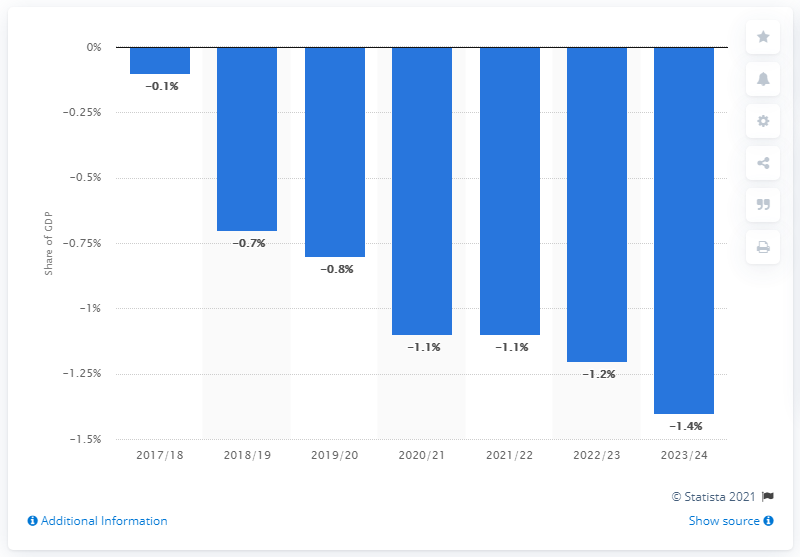How has the UK's budget deficit changed over the past few years according to this chart? The chart demonstrates that the UK's budget deficit has fluctuated somewhat over the past few years. Starting with a smaller deficit of -0.1% of GDP in 2017/18, it increased to -0.7% the following year. By 2020/21, at the peak of the COVID-19 pandemic, the deficit further rose to -1.1%. It appears to remain relatively stable at -1.1% and -1.2% in the subsequent years before reaching an estimate of -1.4% in 2023/24. 